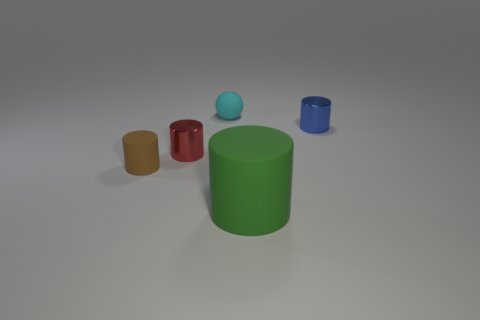Subtract all small red metallic cylinders. How many cylinders are left? 3 Add 1 cylinders. How many objects exist? 6 Subtract all red cylinders. How many cylinders are left? 3 Subtract all cylinders. How many objects are left? 1 Subtract 2 cylinders. How many cylinders are left? 2 Add 1 red shiny blocks. How many red shiny blocks exist? 1 Subtract 0 blue blocks. How many objects are left? 5 Subtract all gray cylinders. Subtract all brown cubes. How many cylinders are left? 4 Subtract all tiny yellow rubber cylinders. Subtract all large green matte cylinders. How many objects are left? 4 Add 4 small brown matte cylinders. How many small brown matte cylinders are left? 5 